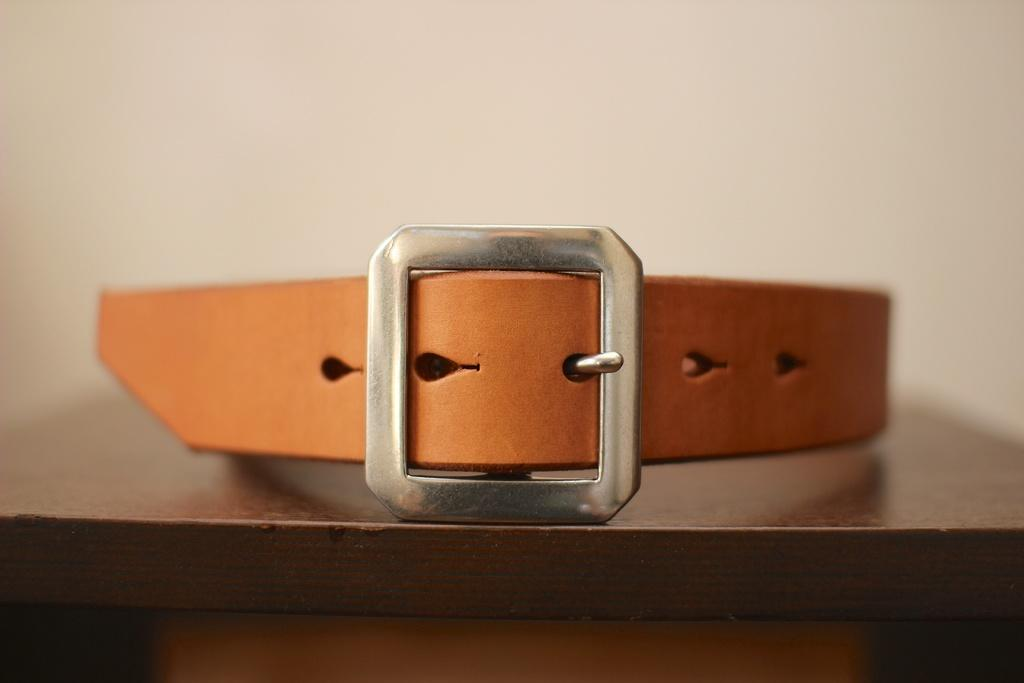What is the main object in the middle of the picture? There is a belt in the middle of the picture. What color is the belt? The belt is brown in color. Can you describe the background of the image? The background of the image is blurred. How does the belt express regret in the image? The belt does not express regret in the image, as it is an inanimate object and cannot have emotions or feelings. 